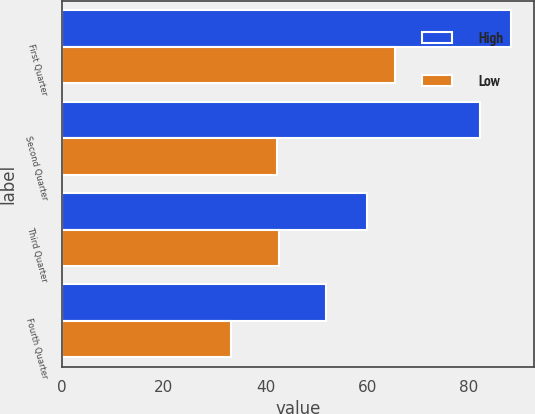Convert chart to OTSL. <chart><loc_0><loc_0><loc_500><loc_500><stacked_bar_chart><ecel><fcel>First Quarter<fcel>Second Quarter<fcel>Third Quarter<fcel>Fourth Quarter<nl><fcel>High<fcel>88.35<fcel>82.25<fcel>60<fcel>51.95<nl><fcel>Low<fcel>65.44<fcel>42.24<fcel>42.67<fcel>33.3<nl></chart> 